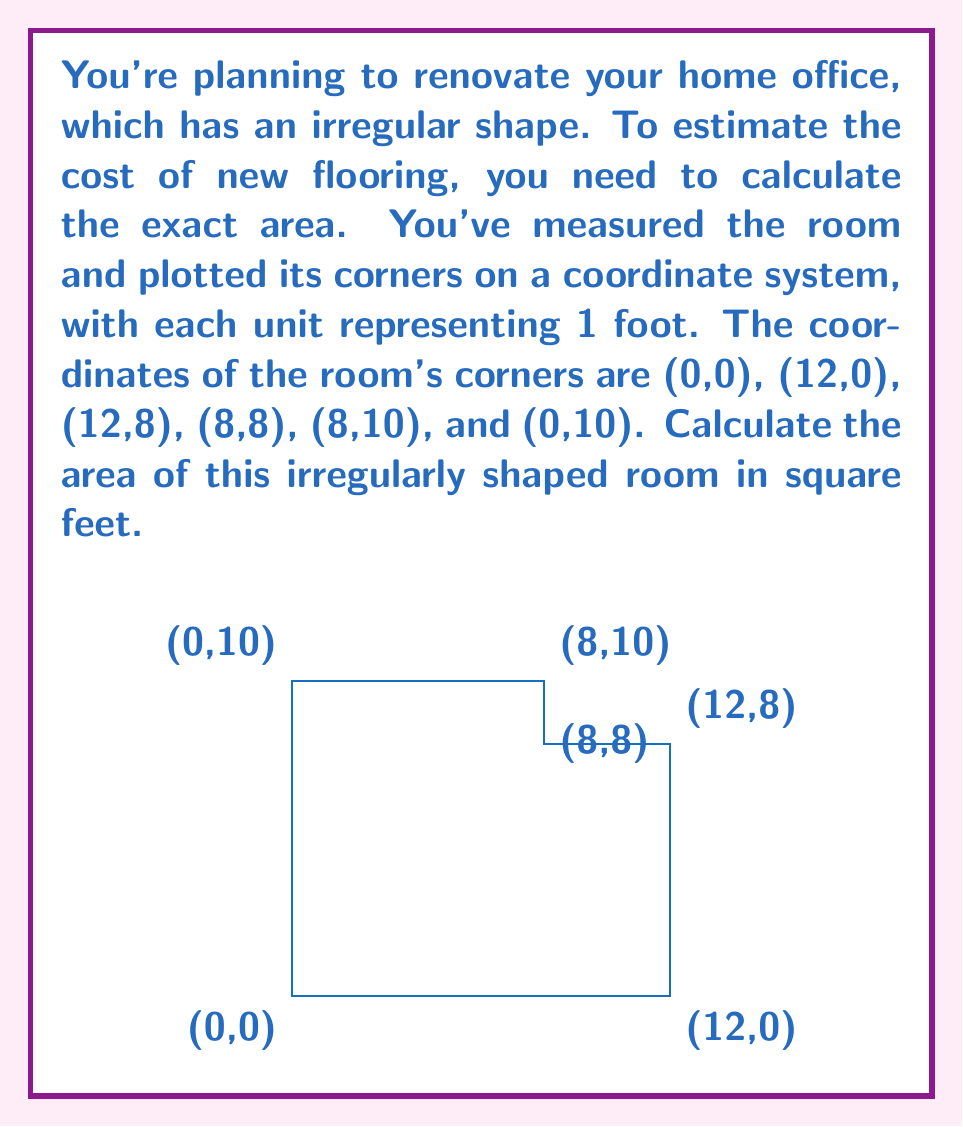Solve this math problem. To calculate the area of this irregularly shaped room, we can use the shoelace formula (also known as the surveyor's formula). This method is particularly useful for calculating the area of any polygon given the coordinates of its vertices.

The shoelace formula is:

$$A = \frac{1}{2}|\sum_{i=1}^{n-1} (x_iy_{i+1} + x_ny_1) - \sum_{i=1}^{n-1} (y_ix_{i+1} + y_nx_1)|$$

Where $(x_i, y_i)$ are the coordinates of the $i$-th vertex.

Let's apply this formula to our room:

1) First, let's list our coordinates in order:
   $(0,0), (12,0), (12,8), (8,8), (8,10), (0,10)$

2) Now, let's calculate the first sum:
   $$(0 \cdot 0) + (12 \cdot 8) + (12 \cdot 8) + (8 \cdot 10) + (8 \cdot 10) + (0 \cdot 0) = 0 + 96 + 96 + 80 + 80 + 0 = 352$$

3) Calculate the second sum:
   $$(0 \cdot 12) + (0 \cdot 12) + (8 \cdot 8) + (8 \cdot 8) + (10 \cdot 0) + (10 \cdot 0) = 0 + 0 + 64 + 64 + 0 + 0 = 128$$

4) Subtract the second sum from the first:
   $$352 - 128 = 224$$

5) Multiply by 1/2:
   $$\frac{1}{2} \cdot 224 = 112$$

Therefore, the area of the room is 112 square feet.
Answer: The area of the irregularly shaped room is 112 square feet. 